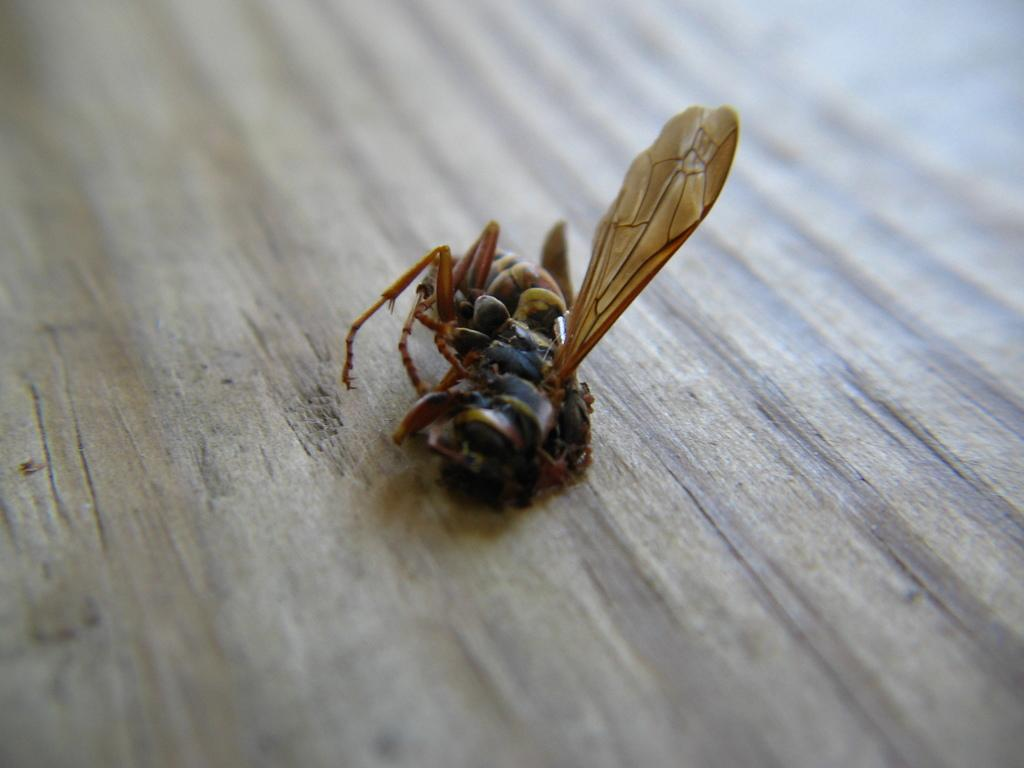What is present on the wooden surface in the image? There is a fly on the wooden surface in the image. Can you describe the wooden surface in the image? The wooden surface is the background on which the fly is present. What type of shoes is the pig wearing in the image? There is no pig or shoes present in the image; it only features a fly on a wooden surface. 